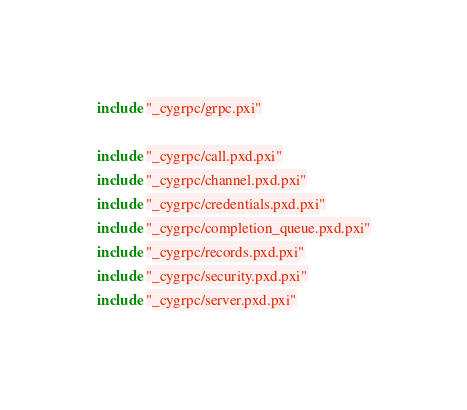<code> <loc_0><loc_0><loc_500><loc_500><_Cython_>include "_cygrpc/grpc.pxi"

include "_cygrpc/call.pxd.pxi"
include "_cygrpc/channel.pxd.pxi"
include "_cygrpc/credentials.pxd.pxi"
include "_cygrpc/completion_queue.pxd.pxi"
include "_cygrpc/records.pxd.pxi"
include "_cygrpc/security.pxd.pxi"
include "_cygrpc/server.pxd.pxi"
</code> 